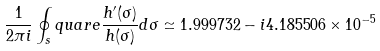<formula> <loc_0><loc_0><loc_500><loc_500>\frac { 1 } { 2 \pi i } \oint _ { s } q u a r e \frac { h ^ { \prime } ( \sigma ) } { h ( \sigma ) } d \sigma \simeq 1 . 9 9 9 7 3 2 - i 4 . 1 8 5 5 0 6 \times 1 0 ^ { - 5 }</formula> 